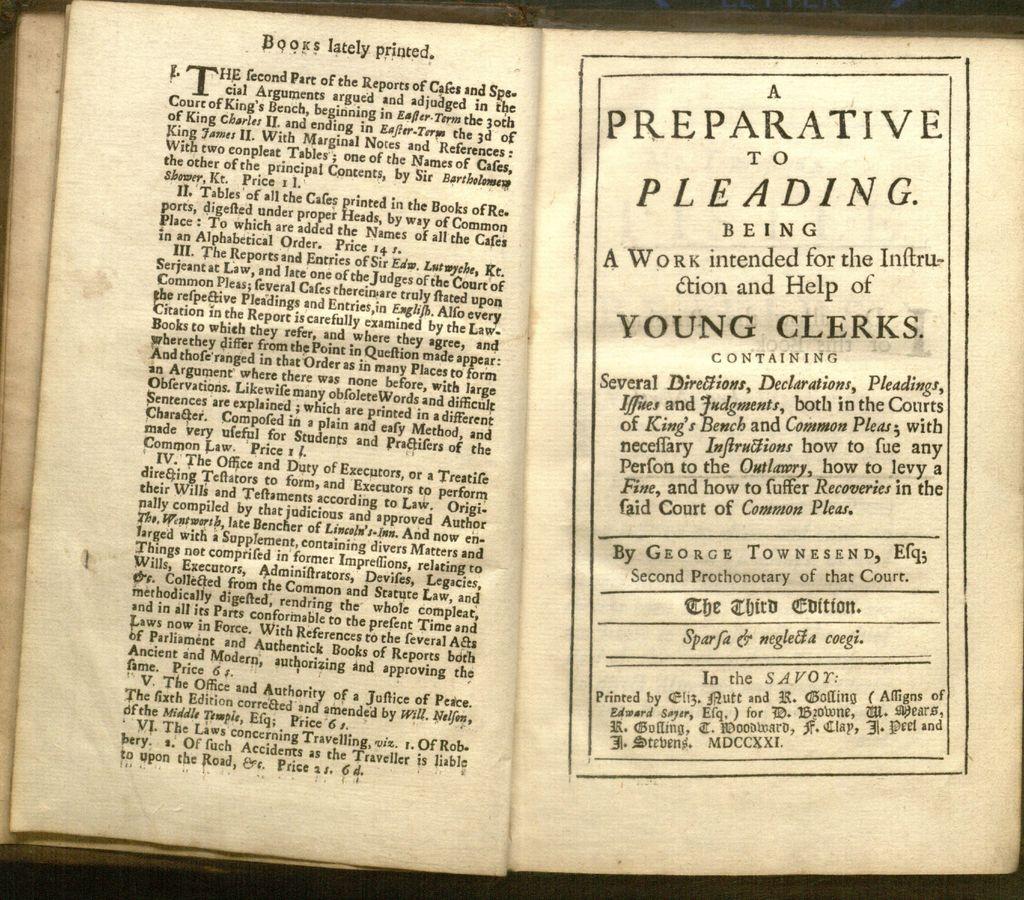What is this work intended for?
Provide a succinct answer. The instruction and help of young clerks. 